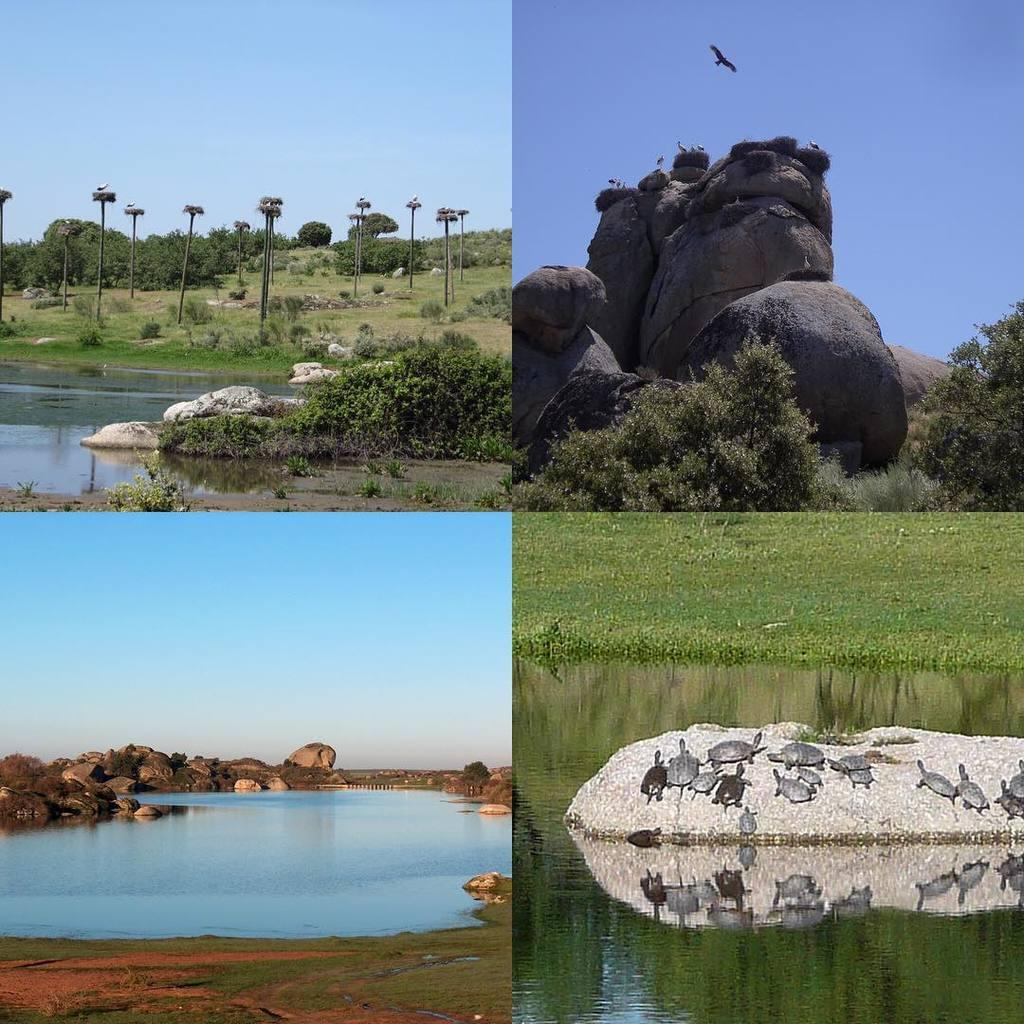What type of artwork is the image? The image is a collage. What natural elements can be seen in the image? There are trees, rocks, plants, and water visible in the image. Are there any animals present in the image? Yes, there are tortoises on a stone in the image. What is happening in the sky in the image? There is a bird flying in the sky in the image. What is the limit of zinc in the image? There is no mention of zinc in the image, so it is not possible to determine a limit for it. How many people are in the crowd in the image? There is no crowd present in the image, so it is not possible to determine the number of people. 